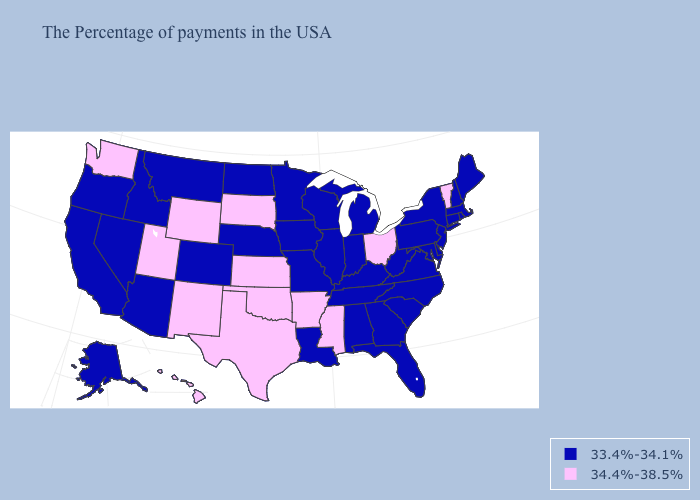What is the value of California?
Keep it brief. 33.4%-34.1%. Which states have the lowest value in the USA?
Write a very short answer. Maine, Massachusetts, Rhode Island, New Hampshire, Connecticut, New York, New Jersey, Delaware, Maryland, Pennsylvania, Virginia, North Carolina, South Carolina, West Virginia, Florida, Georgia, Michigan, Kentucky, Indiana, Alabama, Tennessee, Wisconsin, Illinois, Louisiana, Missouri, Minnesota, Iowa, Nebraska, North Dakota, Colorado, Montana, Arizona, Idaho, Nevada, California, Oregon, Alaska. What is the value of Idaho?
Short answer required. 33.4%-34.1%. Name the states that have a value in the range 34.4%-38.5%?
Be succinct. Vermont, Ohio, Mississippi, Arkansas, Kansas, Oklahoma, Texas, South Dakota, Wyoming, New Mexico, Utah, Washington, Hawaii. Does Arizona have a higher value than Texas?
Quick response, please. No. Does the map have missing data?
Short answer required. No. What is the highest value in the Northeast ?
Give a very brief answer. 34.4%-38.5%. How many symbols are there in the legend?
Give a very brief answer. 2. What is the value of Tennessee?
Quick response, please. 33.4%-34.1%. What is the value of Missouri?
Answer briefly. 33.4%-34.1%. Among the states that border Wyoming , does Idaho have the highest value?
Quick response, please. No. Which states have the lowest value in the USA?
Concise answer only. Maine, Massachusetts, Rhode Island, New Hampshire, Connecticut, New York, New Jersey, Delaware, Maryland, Pennsylvania, Virginia, North Carolina, South Carolina, West Virginia, Florida, Georgia, Michigan, Kentucky, Indiana, Alabama, Tennessee, Wisconsin, Illinois, Louisiana, Missouri, Minnesota, Iowa, Nebraska, North Dakota, Colorado, Montana, Arizona, Idaho, Nevada, California, Oregon, Alaska. Does Kansas have the highest value in the USA?
Write a very short answer. Yes. What is the lowest value in the USA?
Concise answer only. 33.4%-34.1%. What is the value of Kentucky?
Keep it brief. 33.4%-34.1%. 